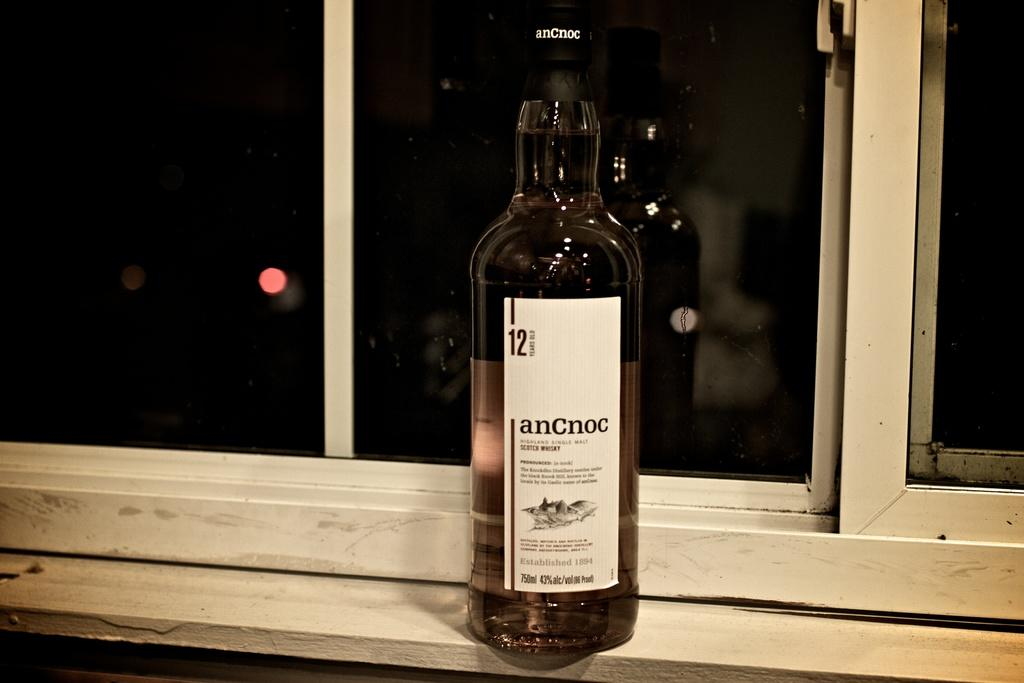<image>
Write a terse but informative summary of the picture. The AnCnoc alcohol bottle is sitting on the window sill. 